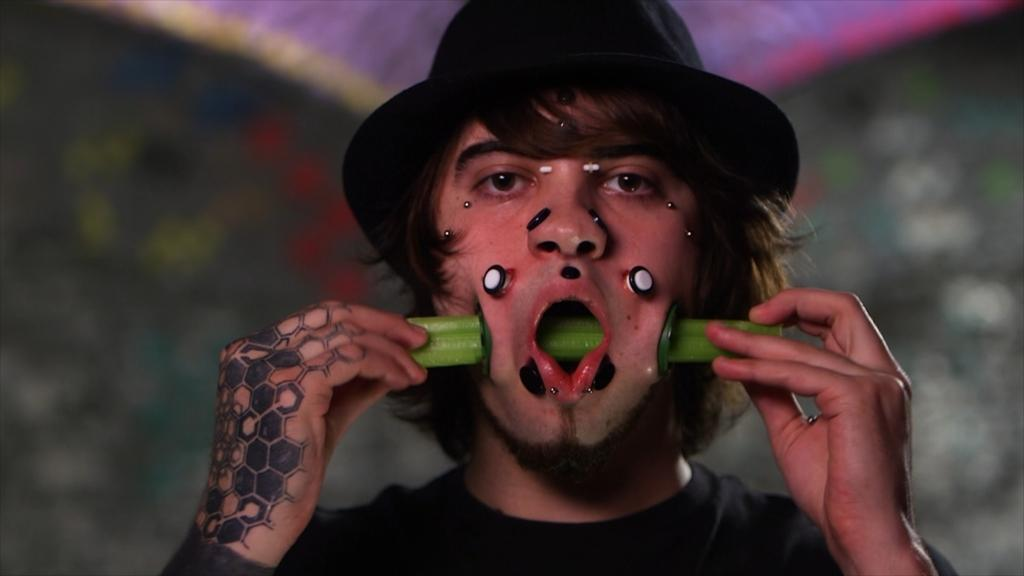Who is present in the image? There is a man in the image. What is the man wearing on his head? The man is wearing a hat. What color is the shirt the man is wearing? The man is wearing a black shirt. What is the man doing in the image? The man is doing something, but we cannot determine the specific action from the provided facts. What type of acoustics can be heard in the image? There is no information about acoustics in the image. Can you see a pail in the image? There is no mention of a pail in the image. Is the man carrying any lumber in the image? There is no mention of lumber in the image. 